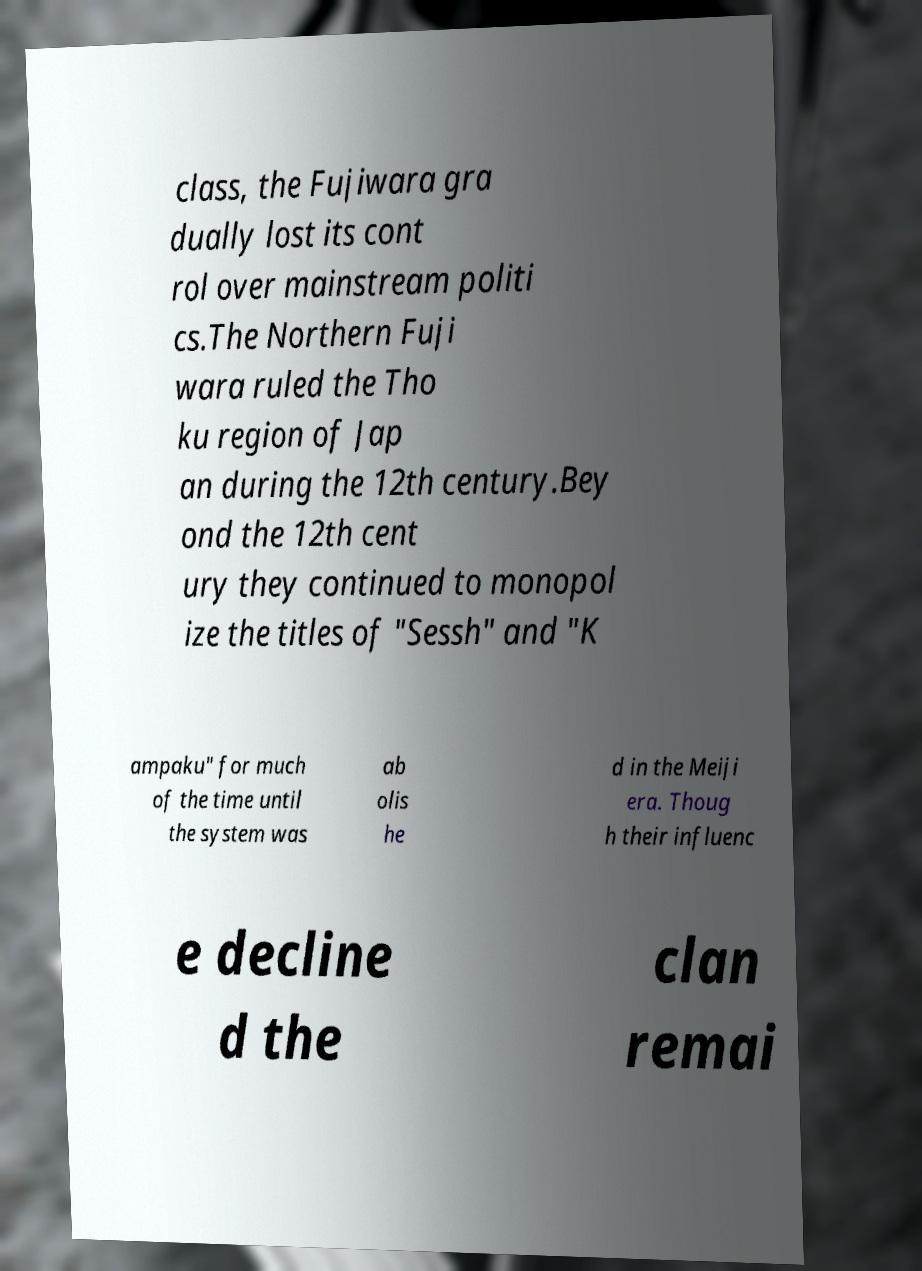Please identify and transcribe the text found in this image. class, the Fujiwara gra dually lost its cont rol over mainstream politi cs.The Northern Fuji wara ruled the Tho ku region of Jap an during the 12th century.Bey ond the 12th cent ury they continued to monopol ize the titles of "Sessh" and "K ampaku" for much of the time until the system was ab olis he d in the Meiji era. Thoug h their influenc e decline d the clan remai 